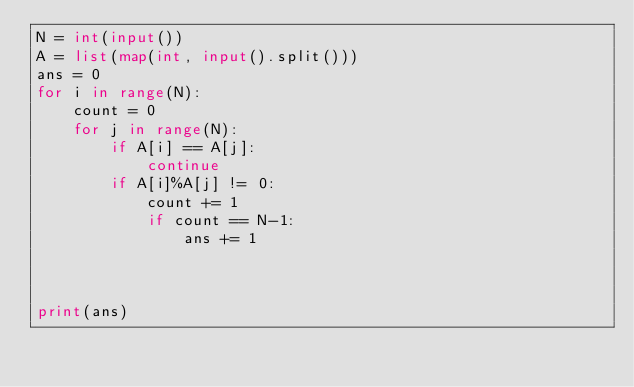Convert code to text. <code><loc_0><loc_0><loc_500><loc_500><_Python_>N = int(input())
A = list(map(int, input().split()))
ans = 0
for i in range(N):
    count = 0
    for j in range(N):
        if A[i] == A[j]:
            continue
        if A[i]%A[j] != 0:
            count += 1
            if count == N-1:
                ans += 1

             

print(ans)


            </code> 